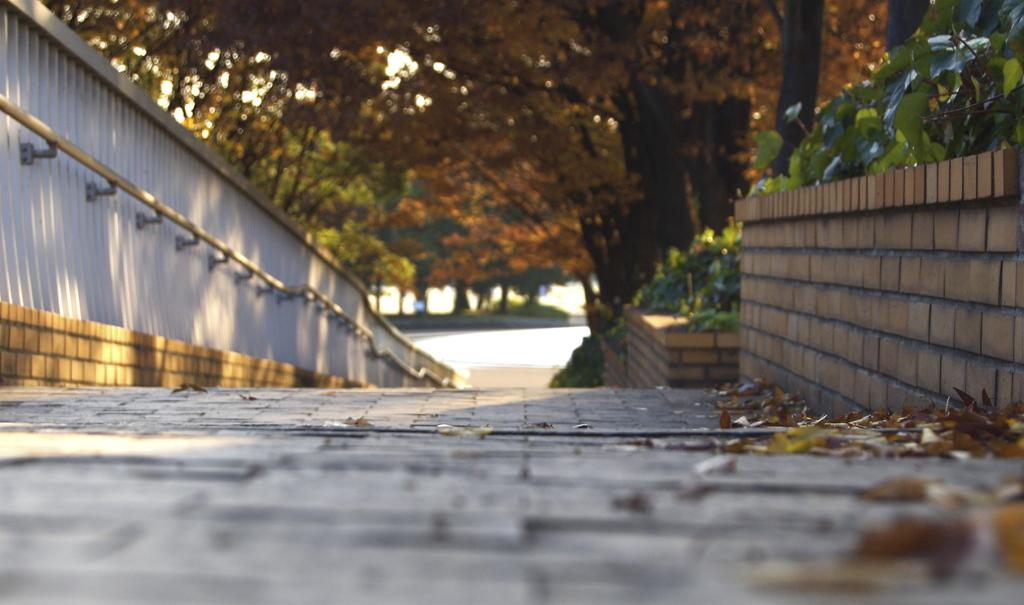What can be seen in front of the road in the image? There is a path in front of the road in the image. What type of vegetation is located beside the path? There are trees beside the path in the image. What is on the left side of the image? There is a wall on the left side of the image. What is attached to the wall? A support pole is attached to the wall in the image. What is the tendency of the tongue in the image? There is no tongue present in the image, so it is not possible to determine its tendency. 